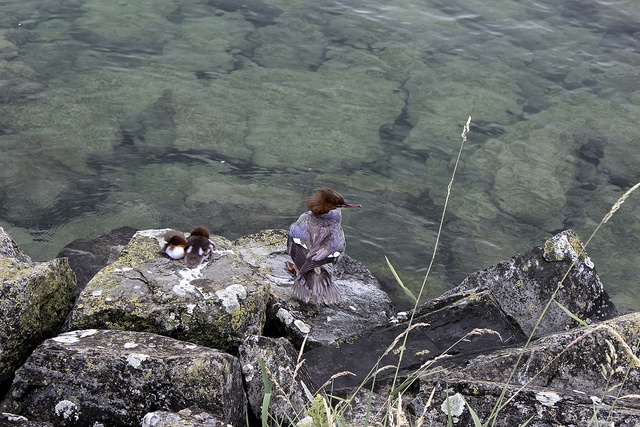Describe the objects in this image and their specific colors. I can see bird in gray, darkgray, and black tones, bird in gray, black, and lavender tones, and bird in gray, black, lavender, and darkgray tones in this image. 